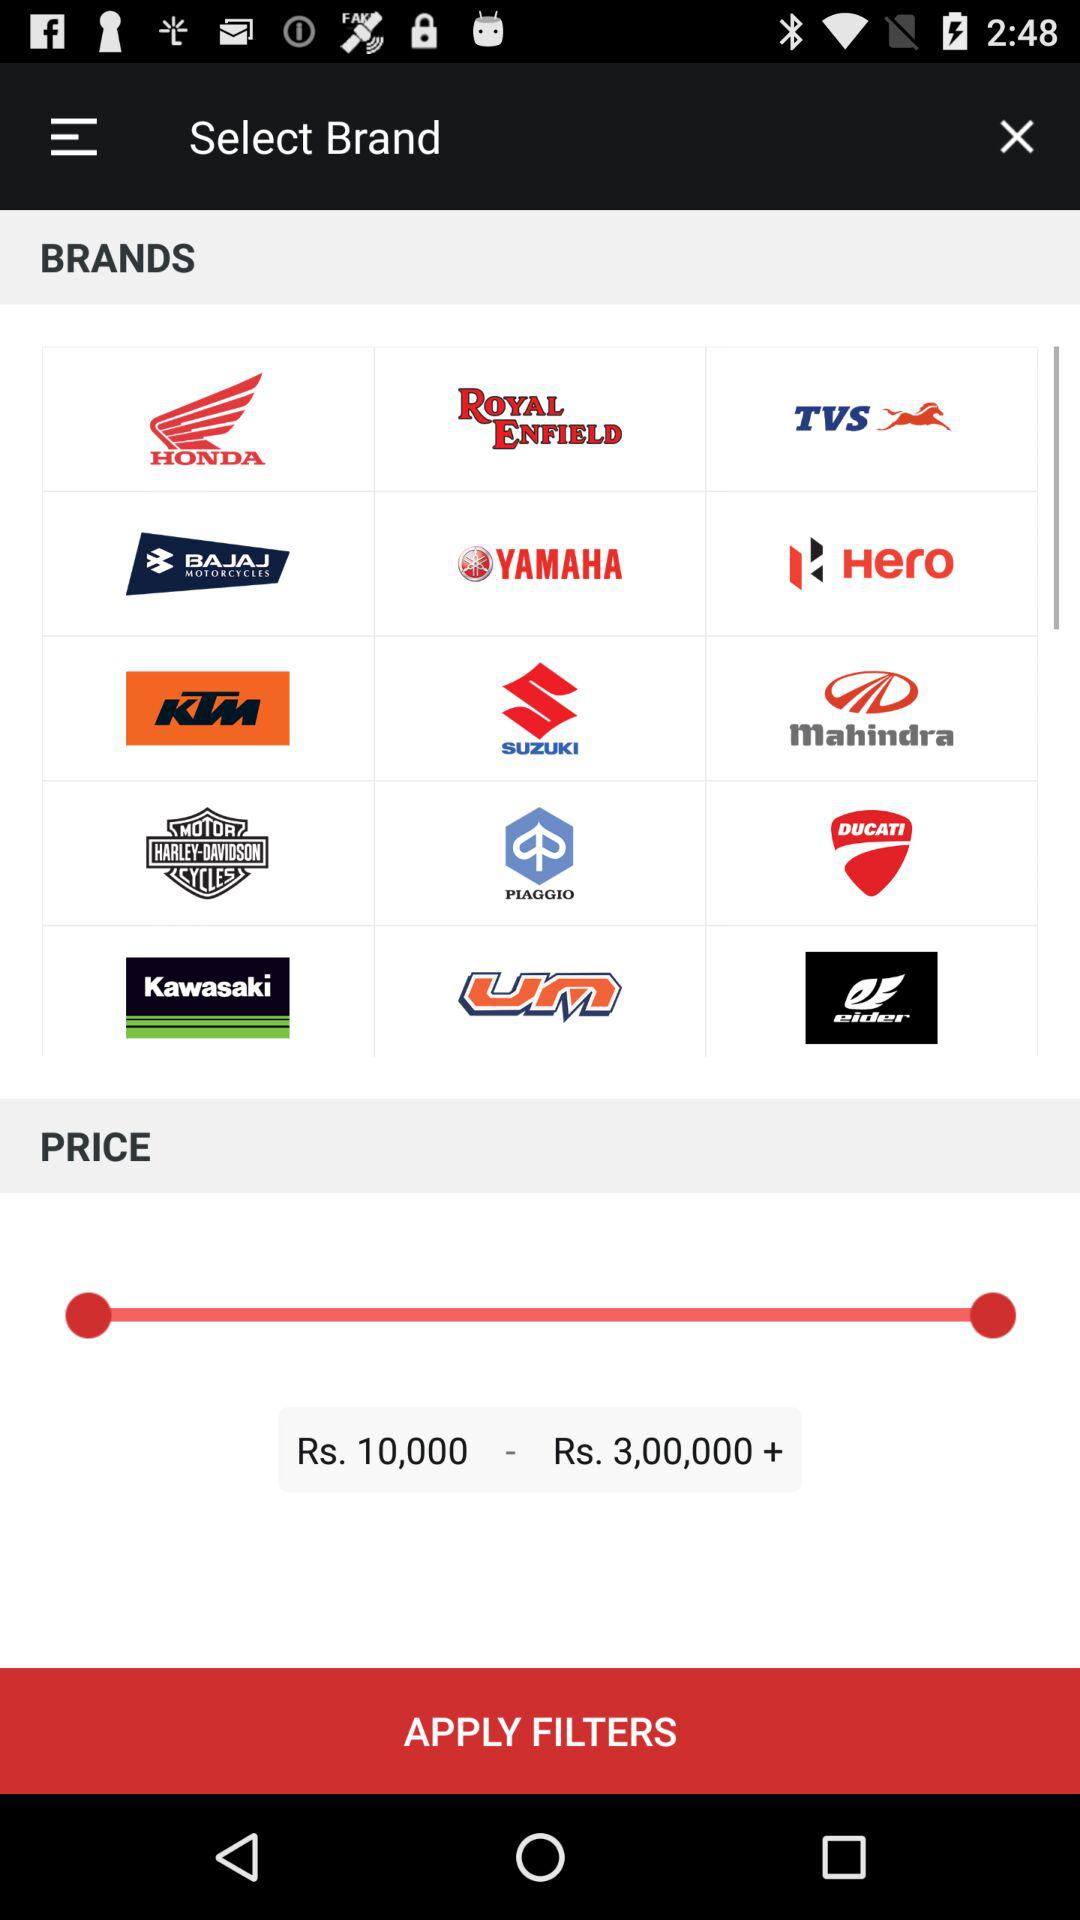How much more does the highest priced motorcycle cost than the lowest priced motorcycle?
Answer the question using a single word or phrase. Rs. 2,90,000 